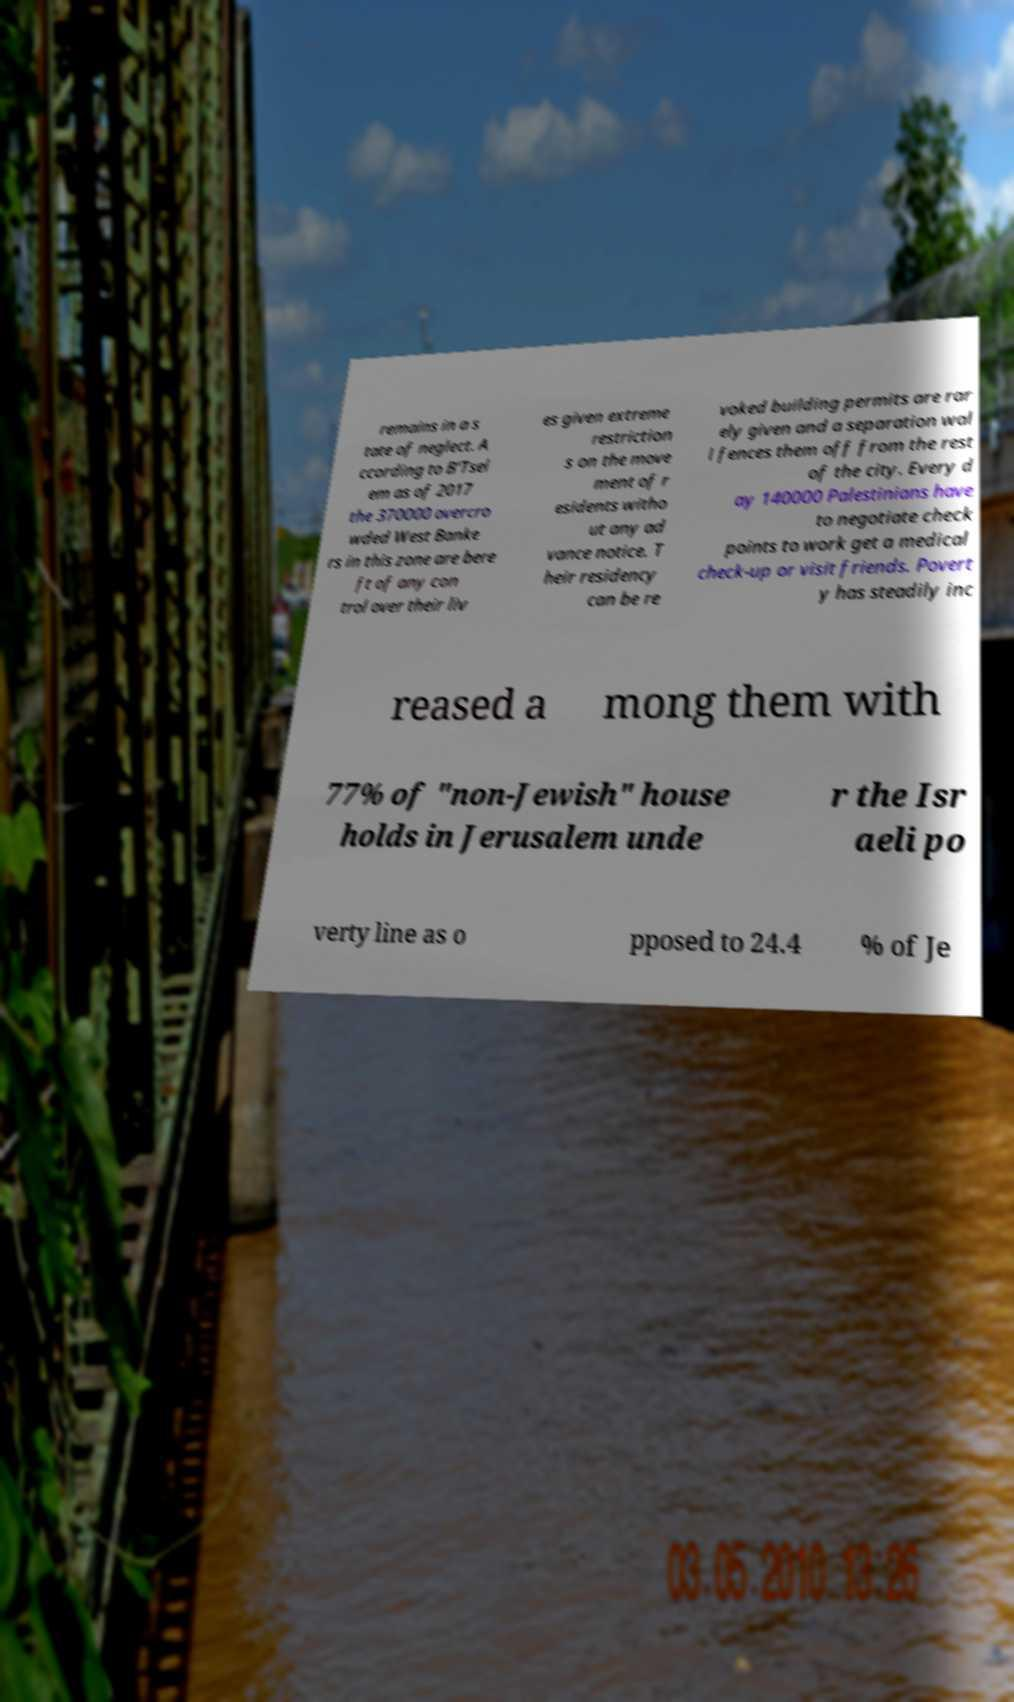I need the written content from this picture converted into text. Can you do that? remains in a s tate of neglect. A ccording to B'Tsel em as of 2017 the 370000 overcro wded West Banke rs in this zone are bere ft of any con trol over their liv es given extreme restriction s on the move ment of r esidents witho ut any ad vance notice. T heir residency can be re voked building permits are rar ely given and a separation wal l fences them off from the rest of the city. Every d ay 140000 Palestinians have to negotiate check points to work get a medical check-up or visit friends. Povert y has steadily inc reased a mong them with 77% of "non-Jewish" house holds in Jerusalem unde r the Isr aeli po verty line as o pposed to 24.4 % of Je 